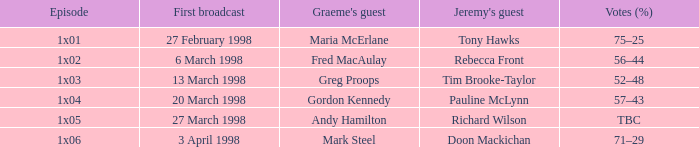What is Votes (%), when First Broadcast is "13 March 1998"? 52–48. 